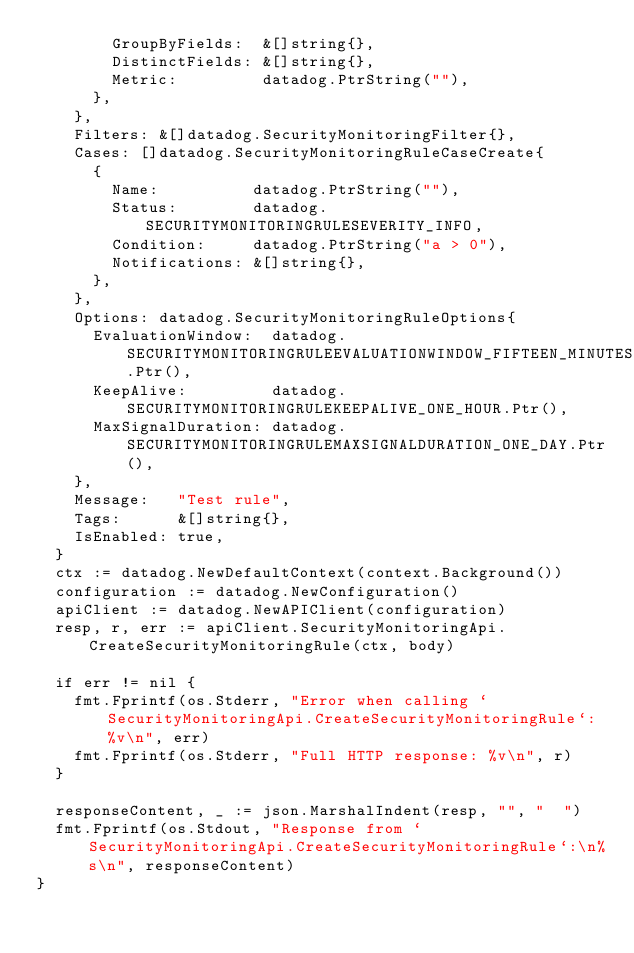Convert code to text. <code><loc_0><loc_0><loc_500><loc_500><_Go_>				GroupByFields:  &[]string{},
				DistinctFields: &[]string{},
				Metric:         datadog.PtrString(""),
			},
		},
		Filters: &[]datadog.SecurityMonitoringFilter{},
		Cases: []datadog.SecurityMonitoringRuleCaseCreate{
			{
				Name:          datadog.PtrString(""),
				Status:        datadog.SECURITYMONITORINGRULESEVERITY_INFO,
				Condition:     datadog.PtrString("a > 0"),
				Notifications: &[]string{},
			},
		},
		Options: datadog.SecurityMonitoringRuleOptions{
			EvaluationWindow:  datadog.SECURITYMONITORINGRULEEVALUATIONWINDOW_FIFTEEN_MINUTES.Ptr(),
			KeepAlive:         datadog.SECURITYMONITORINGRULEKEEPALIVE_ONE_HOUR.Ptr(),
			MaxSignalDuration: datadog.SECURITYMONITORINGRULEMAXSIGNALDURATION_ONE_DAY.Ptr(),
		},
		Message:   "Test rule",
		Tags:      &[]string{},
		IsEnabled: true,
	}
	ctx := datadog.NewDefaultContext(context.Background())
	configuration := datadog.NewConfiguration()
	apiClient := datadog.NewAPIClient(configuration)
	resp, r, err := apiClient.SecurityMonitoringApi.CreateSecurityMonitoringRule(ctx, body)

	if err != nil {
		fmt.Fprintf(os.Stderr, "Error when calling `SecurityMonitoringApi.CreateSecurityMonitoringRule`: %v\n", err)
		fmt.Fprintf(os.Stderr, "Full HTTP response: %v\n", r)
	}

	responseContent, _ := json.MarshalIndent(resp, "", "  ")
	fmt.Fprintf(os.Stdout, "Response from `SecurityMonitoringApi.CreateSecurityMonitoringRule`:\n%s\n", responseContent)
}
</code> 